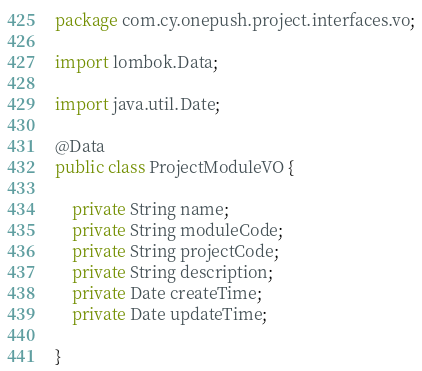Convert code to text. <code><loc_0><loc_0><loc_500><loc_500><_Java_>package com.cy.onepush.project.interfaces.vo;

import lombok.Data;

import java.util.Date;

@Data
public class ProjectModuleVO {

    private String name;
    private String moduleCode;
    private String projectCode;
    private String description;
    private Date createTime;
    private Date updateTime;

}
</code> 